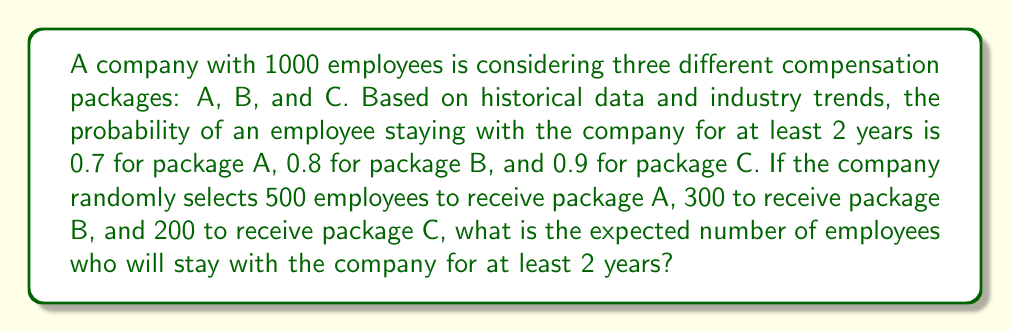What is the answer to this math problem? To solve this problem, we'll use the concept of expected value from statistical mechanics. Let's break it down step-by-step:

1. Define the random variable:
   Let X be the number of employees who stay for at least 2 years.

2. Calculate the expected value for each package:
   - Package A: $E(X_A) = 500 \times 0.7 = 350$
   - Package B: $E(X_B) = 300 \times 0.8 = 240$
   - Package C: $E(X_C) = 200 \times 0.9 = 180$

3. Use the linearity of expectation:
   The total expected number of employees staying is the sum of the expected values for each package.

   $E(X_{total}) = E(X_A) + E(X_B) + E(X_C)$

4. Calculate the total expected value:
   $E(X_{total}) = 350 + 240 + 180 = 770$

Therefore, the expected number of employees who will stay with the company for at least 2 years is 770.
Answer: 770 employees 